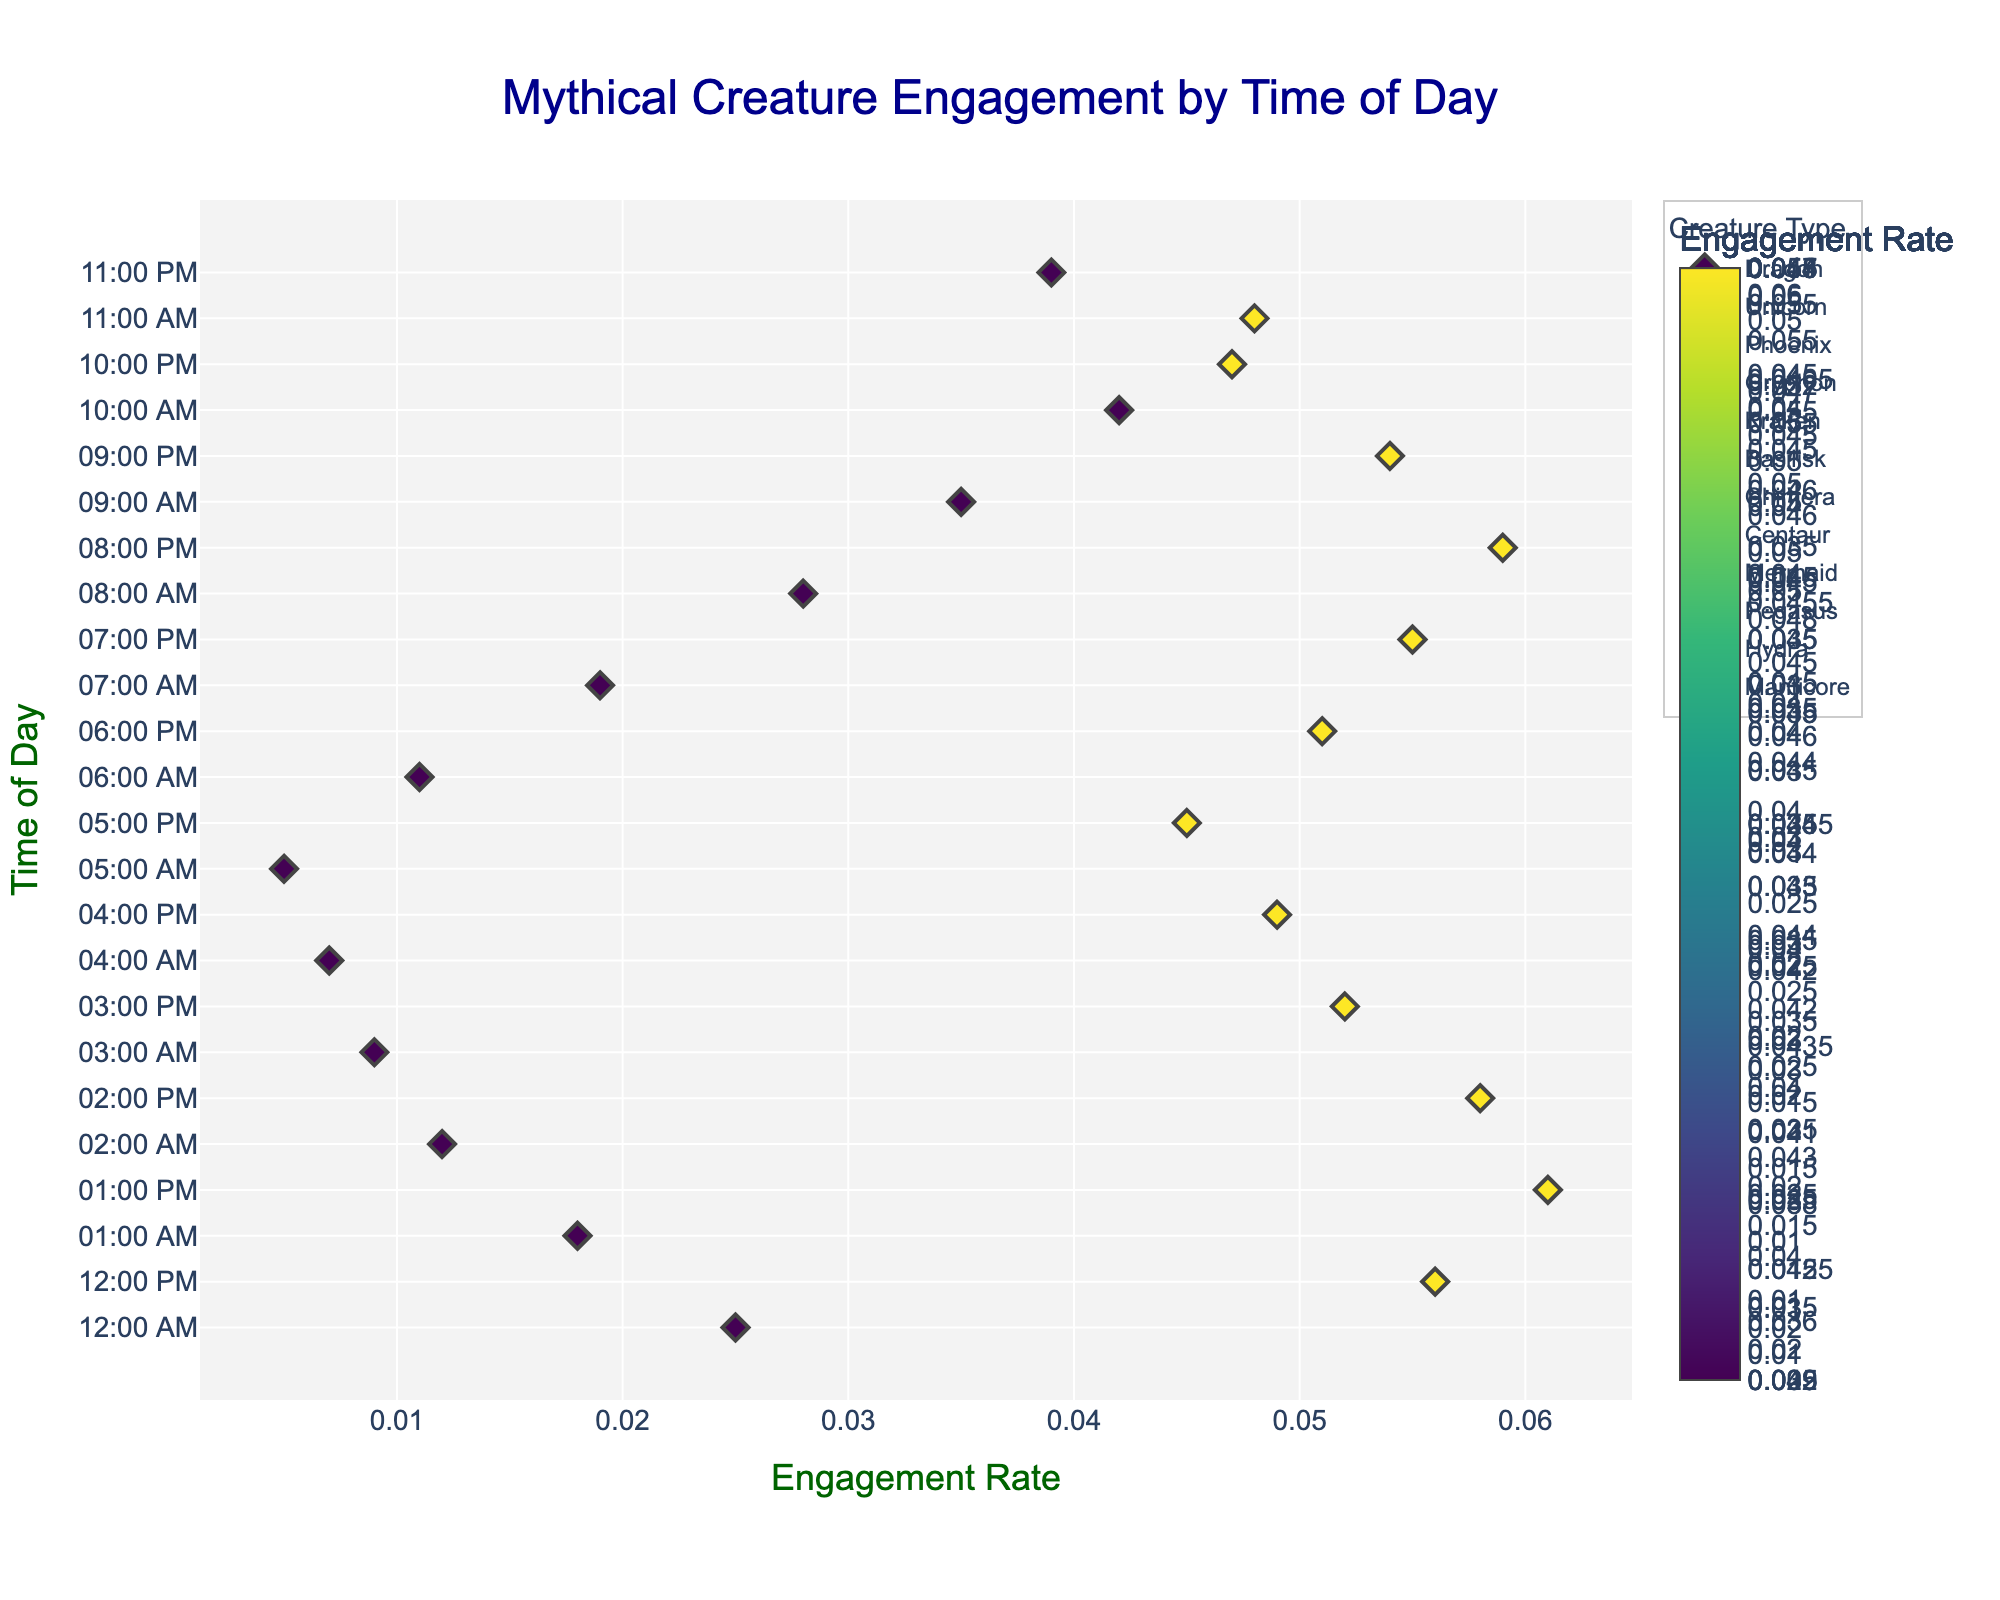What's the title of the figure? The title of the figure is displayed at the top in a larger font size and darker blue color. It summarizes the content of the plot and gives a clear idea about what the figure represents.
Answer: Mythical Creature Engagement by Time of Day What are the axes labels? The x-axis and y-axis labels can be seen on the horizontal and vertical axes, respectively. They provide context on what the axes represent. The x-axis is titled "Engagement Rate" in dark green, and the y-axis is titled "Time of Day," also in dark green.
Answer: Engagement Rate, Time of Day Which mythical creature has the highest engagement rate? By checking the farthest right data points on the x-axis (Engagement Rate), you can identify the highest engagement rate, which is associated with the creature type. The highest engagement rate is 0.061, and it occurs at 13:00 for the Unicorn.
Answer: Unicorn At what time of day does the Mermaid receive the highest engagement rate? Identify the data points associated with the Mermaid and check their positions on the x-axis for their engagement rates. The highest engagement rate for the Mermaid is 0.059, and it occurs at 20:00.
Answer: 20:00 Compare the engagement rates of Dragons at midnight and noon. Which time has a higher rate? Identify the data points for the Dragon at 00:00 and 12:00, then compare their positions on the x-axis. The engagement rate at midnight (00:00) is 0.025, and at noon (12:00), it is 0.056. Noon has a higher rate.
Answer: Noon What is the average engagement rate of the Phoenix? Identify each engagement rate data point for the Phoenix, sum them up, and divide by the number of points. The rates are 0.012 (02:00) and 0.058 (14:00); their sum is 0.070, and there are 2 points, so the average is 0.070 / 2 = 0.035.
Answer: 0.035 Which creature has the most consistent engagement across different times of the day? Consistency can be inferred through minimal variation in engagement rates across the day. By visually inspecting the range of engagement rates for each creature, the Gryphon, which ranges from 0.009 (03:00) to 0.052 (15:00), seems the most consistent.
Answer: Gryphon How does the engagement rate for the Hydra at 10:00 compare to its rate at 22:00? Identify the Hydra's data points at 10:00 and 22:00 on the x-axis. At 10:00, the rate is 0.042, and at 22:00, it is 0.047. The engagement rate is slightly higher at 22:00.
Answer: 22:00 What color represents the highest engagement rate and what does that indicate about the highest engagement rate's creature and time? Check the color bar legend to see which color corresponds to the highest engagement rate and relate it back to the data point with that color. The most intense color on the Viridis scale indicates the highest rate (0.061), representing the Unicorn at 13:00.
Answer: Dark color represents Unicorn at 13:00 Which time frame has the overall highest engagement rates for all creatures? By examining the density and height of the markers along the x-axis, afternoon hours (12:00 to 20:00) seem to show higher overall engagement rates across multiple creatures.
Answer: 12:00 to 20:00 